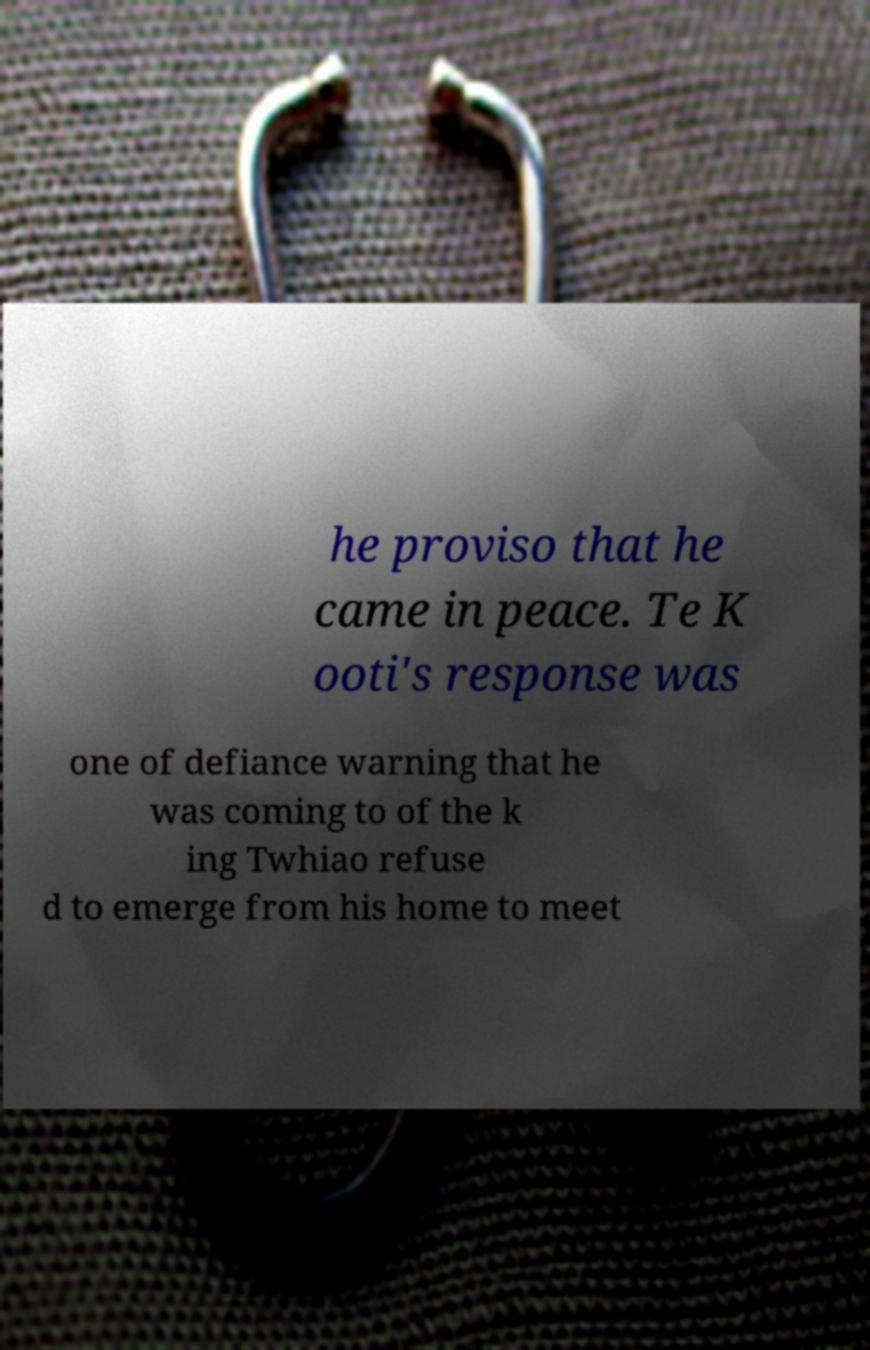Can you read and provide the text displayed in the image?This photo seems to have some interesting text. Can you extract and type it out for me? he proviso that he came in peace. Te K ooti's response was one of defiance warning that he was coming to of the k ing Twhiao refuse d to emerge from his home to meet 